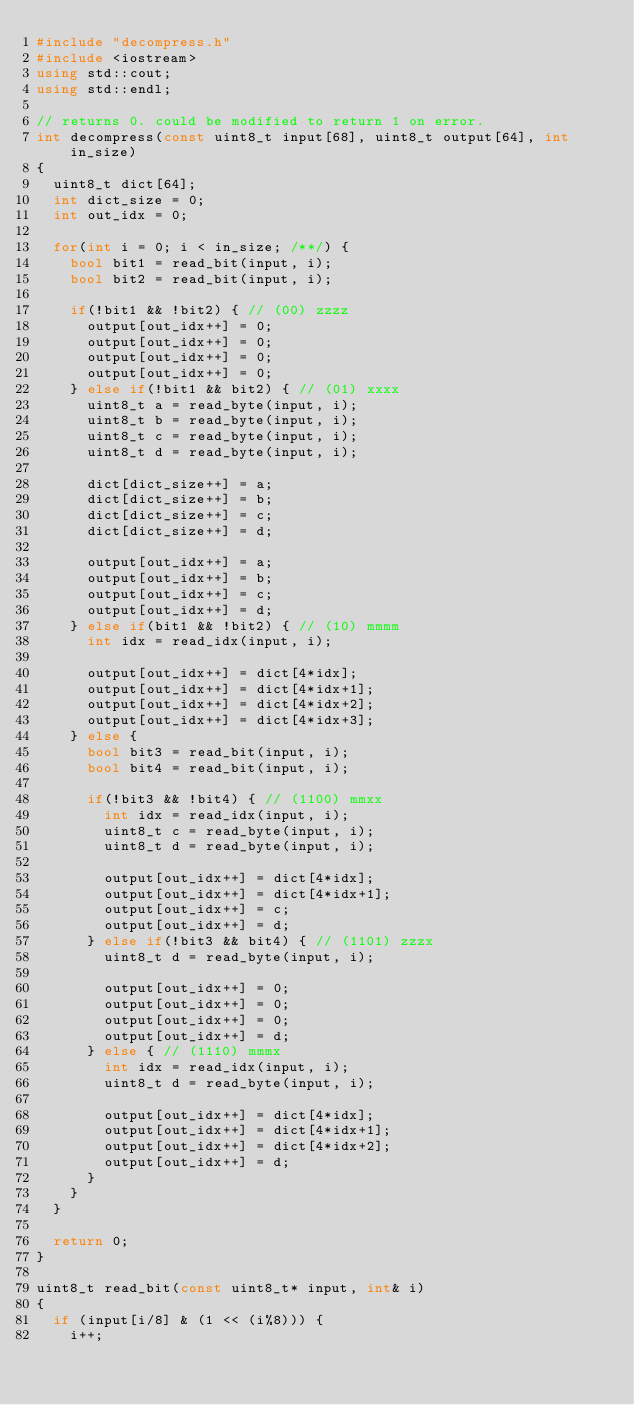<code> <loc_0><loc_0><loc_500><loc_500><_C++_>#include "decompress.h"
#include <iostream>
using std::cout;
using std::endl;

// returns 0. could be modified to return 1 on error.
int decompress(const uint8_t input[68], uint8_t output[64], int in_size)
{
	uint8_t dict[64];
	int dict_size = 0;
	int out_idx = 0;

	for(int i = 0; i < in_size; /**/) {
		bool bit1 = read_bit(input, i);
		bool bit2 = read_bit(input, i);

		if(!bit1 && !bit2) { // (00) zzzz
			output[out_idx++] = 0;
			output[out_idx++] = 0;
			output[out_idx++] = 0;
			output[out_idx++] = 0;
		} else if(!bit1 && bit2) { // (01) xxxx
			uint8_t a = read_byte(input, i);
			uint8_t b = read_byte(input, i);
			uint8_t c = read_byte(input, i);
			uint8_t d = read_byte(input, i);
			
			dict[dict_size++] = a;
			dict[dict_size++] = b;
			dict[dict_size++] = c;
			dict[dict_size++] = d;

			output[out_idx++] = a;
			output[out_idx++] = b;
			output[out_idx++] = c;
			output[out_idx++] = d;
		} else if(bit1 && !bit2) { // (10) mmmm
			int idx = read_idx(input, i); 

			output[out_idx++] = dict[4*idx];
			output[out_idx++] = dict[4*idx+1];
			output[out_idx++] = dict[4*idx+2];
			output[out_idx++] = dict[4*idx+3];
		} else {
			bool bit3 = read_bit(input, i);
			bool bit4 = read_bit(input, i);

			if(!bit3 && !bit4) { // (1100) mmxx
				int idx = read_idx(input, i);
				uint8_t c = read_byte(input, i);
				uint8_t d = read_byte(input, i);

				output[out_idx++] = dict[4*idx];
				output[out_idx++] = dict[4*idx+1];
				output[out_idx++] = c;
				output[out_idx++] = d;
			} else if(!bit3 && bit4) { // (1101) zzzx
				uint8_t d = read_byte(input, i);
				
				output[out_idx++] = 0;
				output[out_idx++] = 0;
				output[out_idx++] = 0;
				output[out_idx++] = d;
			} else { // (1110) mmmx
				int idx = read_idx(input, i);
				uint8_t d = read_byte(input, i);

				output[out_idx++] = dict[4*idx];
				output[out_idx++] = dict[4*idx+1];
				output[out_idx++] = dict[4*idx+2];
				output[out_idx++] = d;
			}
		}
	}

	return 0;
}

uint8_t read_bit(const uint8_t* input, int& i)
{
	if (input[i/8] & (1 << (i%8))) {
		i++;</code> 